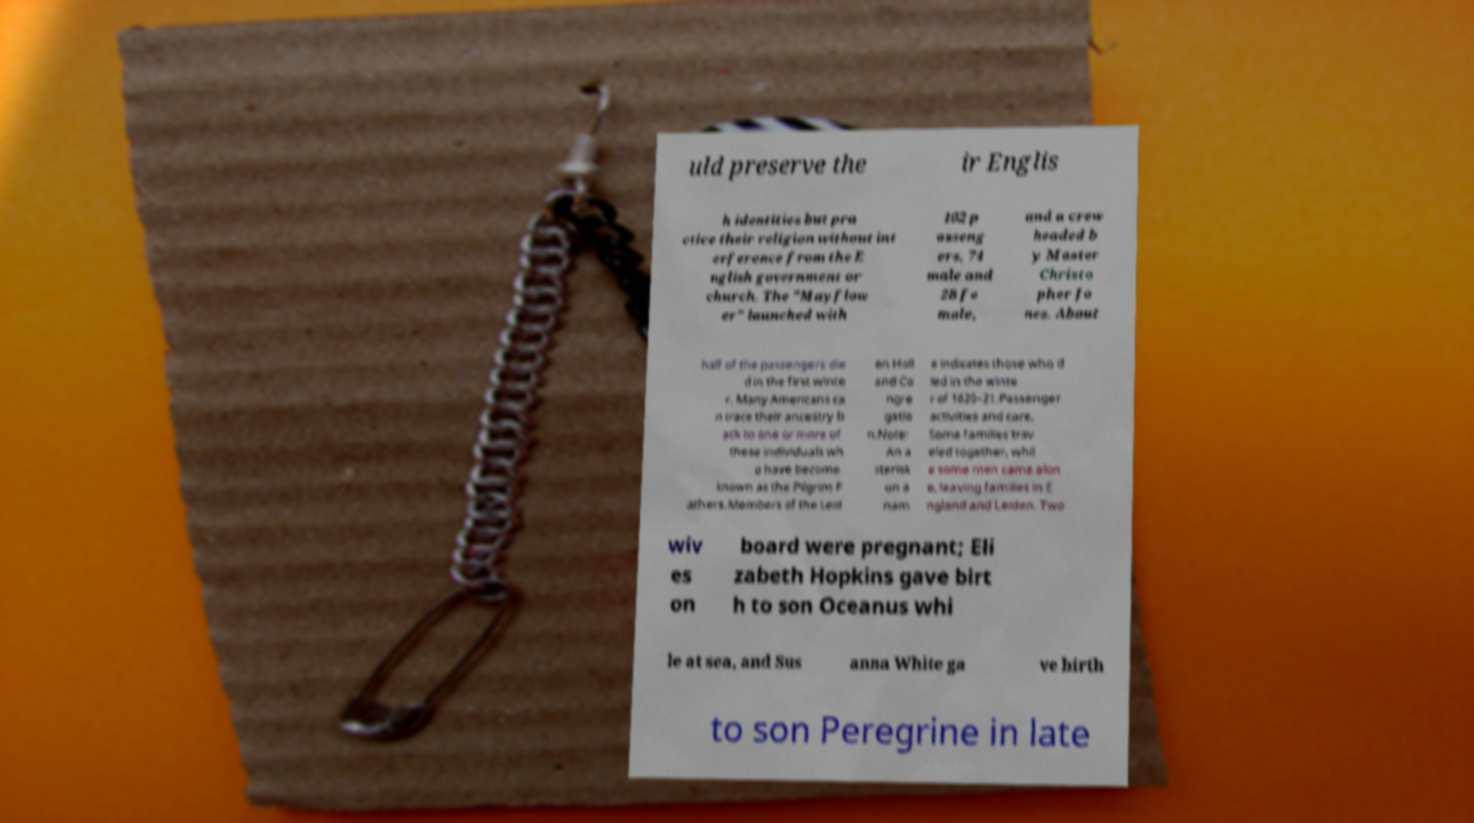Could you assist in decoding the text presented in this image and type it out clearly? uld preserve the ir Englis h identities but pra ctice their religion without int erference from the E nglish government or church. The "Mayflow er" launched with 102 p asseng ers, 74 male and 28 fe male, and a crew headed b y Master Christo pher Jo nes. About half of the passengers die d in the first winte r. Many Americans ca n trace their ancestry b ack to one or more of these individuals wh o have become known as the Pilgrim F athers.Members of the Leid en Holl and Co ngre gatio n.Note: An a sterisk on a nam e indicates those who d ied in the winte r of 1620–21.Passenger activities and care. Some families trav eled together, whil e some men came alon e, leaving families in E ngland and Leiden. Two wiv es on board were pregnant; Eli zabeth Hopkins gave birt h to son Oceanus whi le at sea, and Sus anna White ga ve birth to son Peregrine in late 